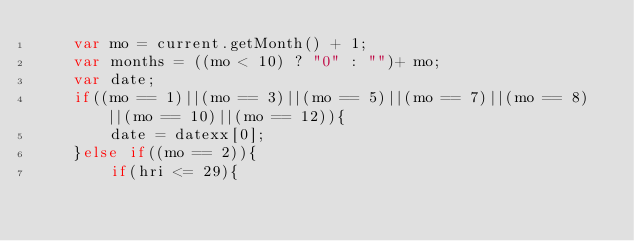<code> <loc_0><loc_0><loc_500><loc_500><_JavaScript_>    var mo = current.getMonth() + 1;
    var months = ((mo < 10) ? "0" : "")+ mo;
    var date;
    if((mo == 1)||(mo == 3)||(mo == 5)||(mo == 7)||(mo == 8)||(mo == 10)||(mo == 12)){
        date = datexx[0];
    }else if((mo == 2)){
        if(hri <= 29){</code> 